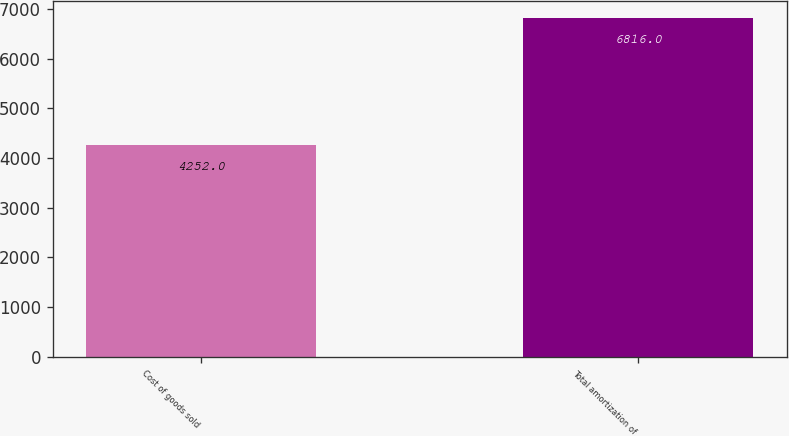<chart> <loc_0><loc_0><loc_500><loc_500><bar_chart><fcel>Cost of goods sold<fcel>Total amortization of<nl><fcel>4252<fcel>6816<nl></chart> 